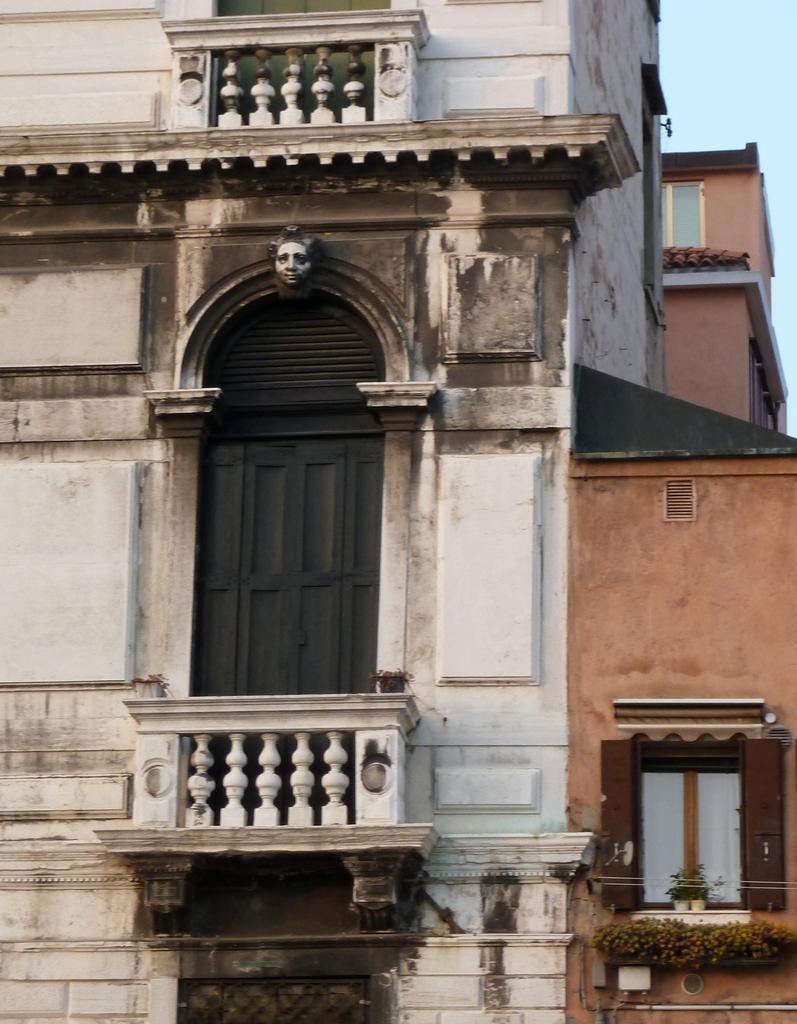How would you summarize this image in a sentence or two? In the picture there is a house present, there is a door and a window present. 